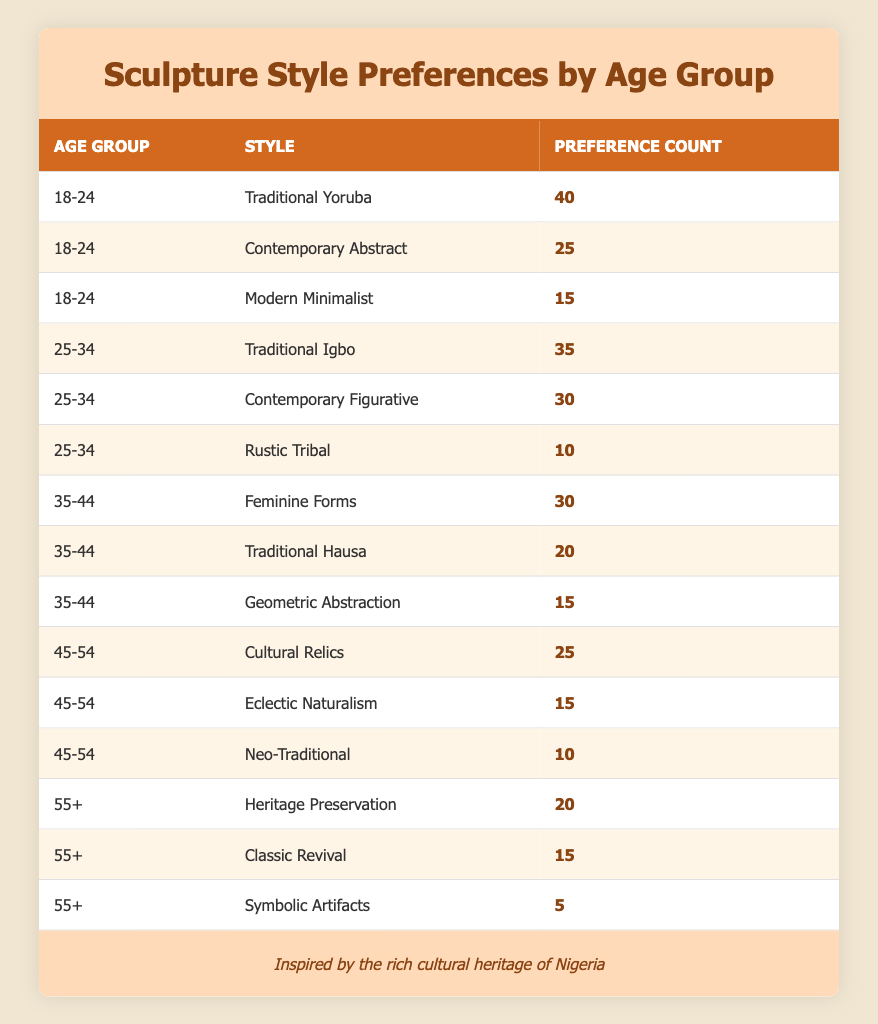What sculpture style is most preferred by the 18-24 age group? The table shows that the most preferred sculpture style for the 18-24 age group is "Traditional Yoruba," with a preference count of 40, which is higher than the other styles in that age group.
Answer: Traditional Yoruba How many people in the 25-34 age group prefer Contemporary Figurative sculptures? From the table, we can see that the preference count for "Contemporary Figurative" in the 25-34 age group is 30.
Answer: 30 What is the combined preference count for all styles in the 45-54 age group? For the 45-54 age group, we add the preference counts: Cultural Relics (25) + Eclectic Naturalism (15) + Neo-Traditional (10) = 50.
Answer: 50 Is there a sculpture style that no one in the 55+ age group preferred? The table indicates that "Symbolic Artifacts" has the lowest preference count of 5 in the 55+ age group, meaning it is not a preferred style, but there is still a count. Therefore, there is no style without any preference in this age group.
Answer: No What is the average preference count for the Traditional styles across all age groups? In the table, the Traditional styles are Traditional Yoruba (40), Traditional Igbo (35), Traditional Hausa (20). We calculate the average: (40 + 35 + 20) / 3 = 95 / 3 = 31.67.
Answer: 31.67 Which age group exhibits the highest preference for Modern Minimalist sculpture? The table indicates that "Modern Minimalist" has a preference count of 15 only within the 18-24 age group, and no count exists for other age groups, so the highest preference is within that group.
Answer: 18-24 Which style has the lowest overall preference count across all age groups? By examining the table, "Symbolic Artifacts" has the lowest preference count of 5, which is less compared to others across all age groups.
Answer: Symbolic Artifacts How many preferences did people indicate for Traditional styles altogether? Traditional styles in the table are Traditional Yoruba (40), Traditional Igbo (35), and Traditional Hausa (20). Adding these gives 40 + 35 + 20 = 95.
Answer: 95 